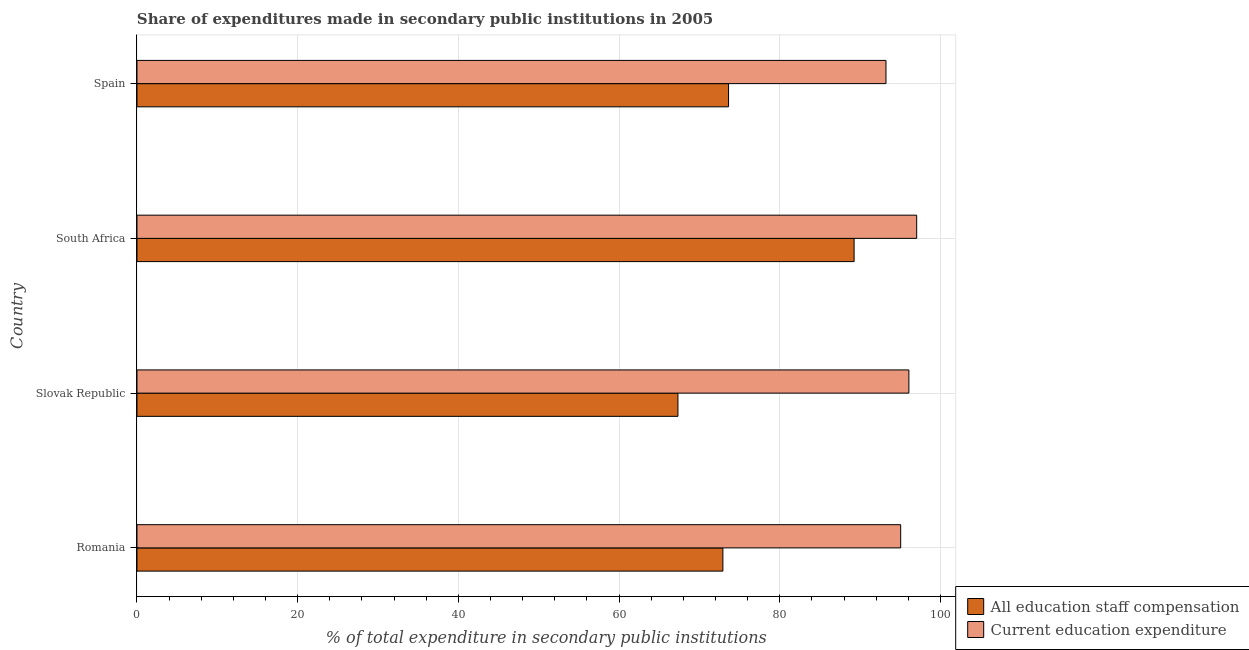How many different coloured bars are there?
Offer a very short reply. 2. Are the number of bars per tick equal to the number of legend labels?
Give a very brief answer. Yes. Are the number of bars on each tick of the Y-axis equal?
Provide a succinct answer. Yes. What is the label of the 1st group of bars from the top?
Keep it short and to the point. Spain. In how many cases, is the number of bars for a given country not equal to the number of legend labels?
Provide a succinct answer. 0. What is the expenditure in staff compensation in Spain?
Give a very brief answer. 73.62. Across all countries, what is the maximum expenditure in staff compensation?
Your response must be concise. 89.25. Across all countries, what is the minimum expenditure in staff compensation?
Provide a succinct answer. 67.32. In which country was the expenditure in staff compensation maximum?
Offer a very short reply. South Africa. In which country was the expenditure in staff compensation minimum?
Provide a short and direct response. Slovak Republic. What is the total expenditure in education in the graph?
Offer a terse response. 381.36. What is the difference between the expenditure in education in Slovak Republic and that in South Africa?
Give a very brief answer. -0.97. What is the difference between the expenditure in education in South Africa and the expenditure in staff compensation in Spain?
Make the answer very short. 23.42. What is the average expenditure in staff compensation per country?
Make the answer very short. 75.78. What is the difference between the expenditure in education and expenditure in staff compensation in Slovak Republic?
Your response must be concise. 28.74. What is the ratio of the expenditure in staff compensation in Romania to that in Slovak Republic?
Ensure brevity in your answer.  1.08. What is the difference between the highest and the second highest expenditure in staff compensation?
Offer a very short reply. 15.63. What is the difference between the highest and the lowest expenditure in staff compensation?
Make the answer very short. 21.93. Is the sum of the expenditure in education in South Africa and Spain greater than the maximum expenditure in staff compensation across all countries?
Make the answer very short. Yes. What does the 1st bar from the top in Spain represents?
Ensure brevity in your answer.  Current education expenditure. What does the 2nd bar from the bottom in Romania represents?
Offer a terse response. Current education expenditure. How many bars are there?
Your answer should be compact. 8. What is the difference between two consecutive major ticks on the X-axis?
Keep it short and to the point. 20. Where does the legend appear in the graph?
Offer a very short reply. Bottom right. How many legend labels are there?
Ensure brevity in your answer.  2. What is the title of the graph?
Offer a very short reply. Share of expenditures made in secondary public institutions in 2005. Does "Start a business" appear as one of the legend labels in the graph?
Your response must be concise. No. What is the label or title of the X-axis?
Keep it short and to the point. % of total expenditure in secondary public institutions. What is the label or title of the Y-axis?
Your answer should be very brief. Country. What is the % of total expenditure in secondary public institutions of All education staff compensation in Romania?
Provide a succinct answer. 72.92. What is the % of total expenditure in secondary public institutions of Current education expenditure in Romania?
Offer a very short reply. 95.04. What is the % of total expenditure in secondary public institutions of All education staff compensation in Slovak Republic?
Give a very brief answer. 67.32. What is the % of total expenditure in secondary public institutions in Current education expenditure in Slovak Republic?
Offer a very short reply. 96.07. What is the % of total expenditure in secondary public institutions of All education staff compensation in South Africa?
Make the answer very short. 89.25. What is the % of total expenditure in secondary public institutions in Current education expenditure in South Africa?
Offer a terse response. 97.04. What is the % of total expenditure in secondary public institutions in All education staff compensation in Spain?
Your answer should be compact. 73.62. What is the % of total expenditure in secondary public institutions in Current education expenditure in Spain?
Provide a short and direct response. 93.21. Across all countries, what is the maximum % of total expenditure in secondary public institutions in All education staff compensation?
Ensure brevity in your answer.  89.25. Across all countries, what is the maximum % of total expenditure in secondary public institutions of Current education expenditure?
Ensure brevity in your answer.  97.04. Across all countries, what is the minimum % of total expenditure in secondary public institutions in All education staff compensation?
Your answer should be compact. 67.32. Across all countries, what is the minimum % of total expenditure in secondary public institutions in Current education expenditure?
Ensure brevity in your answer.  93.21. What is the total % of total expenditure in secondary public institutions in All education staff compensation in the graph?
Offer a very short reply. 303.11. What is the total % of total expenditure in secondary public institutions in Current education expenditure in the graph?
Offer a terse response. 381.36. What is the difference between the % of total expenditure in secondary public institutions in All education staff compensation in Romania and that in Slovak Republic?
Your answer should be very brief. 5.59. What is the difference between the % of total expenditure in secondary public institutions in Current education expenditure in Romania and that in Slovak Republic?
Provide a succinct answer. -1.02. What is the difference between the % of total expenditure in secondary public institutions in All education staff compensation in Romania and that in South Africa?
Offer a very short reply. -16.33. What is the difference between the % of total expenditure in secondary public institutions of Current education expenditure in Romania and that in South Africa?
Offer a terse response. -1.99. What is the difference between the % of total expenditure in secondary public institutions of All education staff compensation in Romania and that in Spain?
Offer a terse response. -0.7. What is the difference between the % of total expenditure in secondary public institutions in Current education expenditure in Romania and that in Spain?
Offer a terse response. 1.83. What is the difference between the % of total expenditure in secondary public institutions in All education staff compensation in Slovak Republic and that in South Africa?
Ensure brevity in your answer.  -21.93. What is the difference between the % of total expenditure in secondary public institutions in Current education expenditure in Slovak Republic and that in South Africa?
Ensure brevity in your answer.  -0.97. What is the difference between the % of total expenditure in secondary public institutions of All education staff compensation in Slovak Republic and that in Spain?
Keep it short and to the point. -6.3. What is the difference between the % of total expenditure in secondary public institutions in Current education expenditure in Slovak Republic and that in Spain?
Your answer should be compact. 2.85. What is the difference between the % of total expenditure in secondary public institutions of All education staff compensation in South Africa and that in Spain?
Make the answer very short. 15.63. What is the difference between the % of total expenditure in secondary public institutions in Current education expenditure in South Africa and that in Spain?
Your answer should be very brief. 3.82. What is the difference between the % of total expenditure in secondary public institutions in All education staff compensation in Romania and the % of total expenditure in secondary public institutions in Current education expenditure in Slovak Republic?
Your response must be concise. -23.15. What is the difference between the % of total expenditure in secondary public institutions in All education staff compensation in Romania and the % of total expenditure in secondary public institutions in Current education expenditure in South Africa?
Offer a terse response. -24.12. What is the difference between the % of total expenditure in secondary public institutions of All education staff compensation in Romania and the % of total expenditure in secondary public institutions of Current education expenditure in Spain?
Offer a very short reply. -20.3. What is the difference between the % of total expenditure in secondary public institutions of All education staff compensation in Slovak Republic and the % of total expenditure in secondary public institutions of Current education expenditure in South Africa?
Provide a short and direct response. -29.71. What is the difference between the % of total expenditure in secondary public institutions of All education staff compensation in Slovak Republic and the % of total expenditure in secondary public institutions of Current education expenditure in Spain?
Give a very brief answer. -25.89. What is the difference between the % of total expenditure in secondary public institutions of All education staff compensation in South Africa and the % of total expenditure in secondary public institutions of Current education expenditure in Spain?
Give a very brief answer. -3.97. What is the average % of total expenditure in secondary public institutions in All education staff compensation per country?
Keep it short and to the point. 75.78. What is the average % of total expenditure in secondary public institutions in Current education expenditure per country?
Offer a very short reply. 95.34. What is the difference between the % of total expenditure in secondary public institutions in All education staff compensation and % of total expenditure in secondary public institutions in Current education expenditure in Romania?
Provide a succinct answer. -22.13. What is the difference between the % of total expenditure in secondary public institutions in All education staff compensation and % of total expenditure in secondary public institutions in Current education expenditure in Slovak Republic?
Offer a terse response. -28.74. What is the difference between the % of total expenditure in secondary public institutions of All education staff compensation and % of total expenditure in secondary public institutions of Current education expenditure in South Africa?
Give a very brief answer. -7.79. What is the difference between the % of total expenditure in secondary public institutions of All education staff compensation and % of total expenditure in secondary public institutions of Current education expenditure in Spain?
Give a very brief answer. -19.59. What is the ratio of the % of total expenditure in secondary public institutions of All education staff compensation in Romania to that in Slovak Republic?
Make the answer very short. 1.08. What is the ratio of the % of total expenditure in secondary public institutions of All education staff compensation in Romania to that in South Africa?
Your answer should be very brief. 0.82. What is the ratio of the % of total expenditure in secondary public institutions in Current education expenditure in Romania to that in South Africa?
Offer a very short reply. 0.98. What is the ratio of the % of total expenditure in secondary public institutions in All education staff compensation in Romania to that in Spain?
Offer a very short reply. 0.99. What is the ratio of the % of total expenditure in secondary public institutions of Current education expenditure in Romania to that in Spain?
Offer a terse response. 1.02. What is the ratio of the % of total expenditure in secondary public institutions of All education staff compensation in Slovak Republic to that in South Africa?
Ensure brevity in your answer.  0.75. What is the ratio of the % of total expenditure in secondary public institutions of Current education expenditure in Slovak Republic to that in South Africa?
Provide a succinct answer. 0.99. What is the ratio of the % of total expenditure in secondary public institutions in All education staff compensation in Slovak Republic to that in Spain?
Your answer should be compact. 0.91. What is the ratio of the % of total expenditure in secondary public institutions of Current education expenditure in Slovak Republic to that in Spain?
Provide a succinct answer. 1.03. What is the ratio of the % of total expenditure in secondary public institutions of All education staff compensation in South Africa to that in Spain?
Your answer should be compact. 1.21. What is the ratio of the % of total expenditure in secondary public institutions in Current education expenditure in South Africa to that in Spain?
Provide a short and direct response. 1.04. What is the difference between the highest and the second highest % of total expenditure in secondary public institutions of All education staff compensation?
Keep it short and to the point. 15.63. What is the difference between the highest and the second highest % of total expenditure in secondary public institutions in Current education expenditure?
Make the answer very short. 0.97. What is the difference between the highest and the lowest % of total expenditure in secondary public institutions in All education staff compensation?
Your answer should be compact. 21.93. What is the difference between the highest and the lowest % of total expenditure in secondary public institutions of Current education expenditure?
Offer a very short reply. 3.82. 